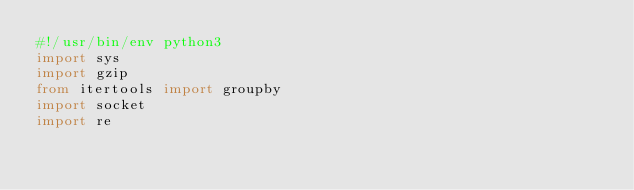<code> <loc_0><loc_0><loc_500><loc_500><_Python_>#!/usr/bin/env python3
import sys
import gzip
from itertools import groupby 
import socket
import re</code> 